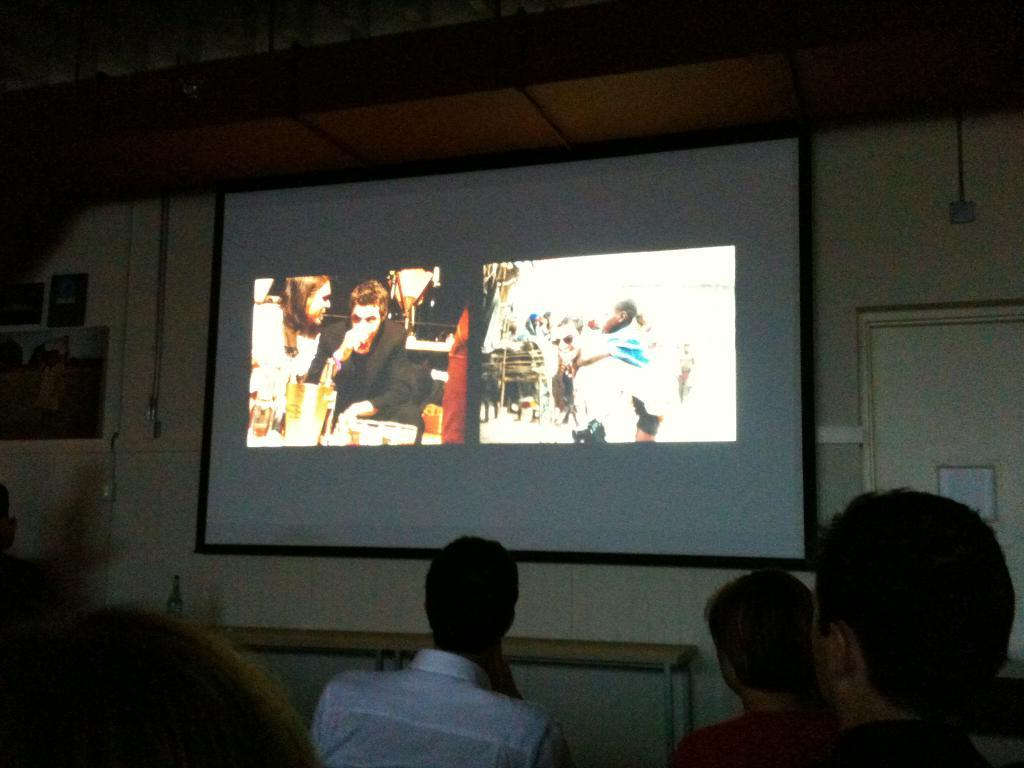What type of space is depicted in the image? There is a room in the image. What is the main feature of the room? There is a projector screen in the room. What are the people in the image doing? The people are sitting in front of the screen and watching it. Can you tell me how many cacti are in the room? There is no cactus present in the image; the room features a projector screen and people watching it. What type of wax is being used by the people in the image? There is no wax mentioned or visible in the image; the people are watching a screen. 